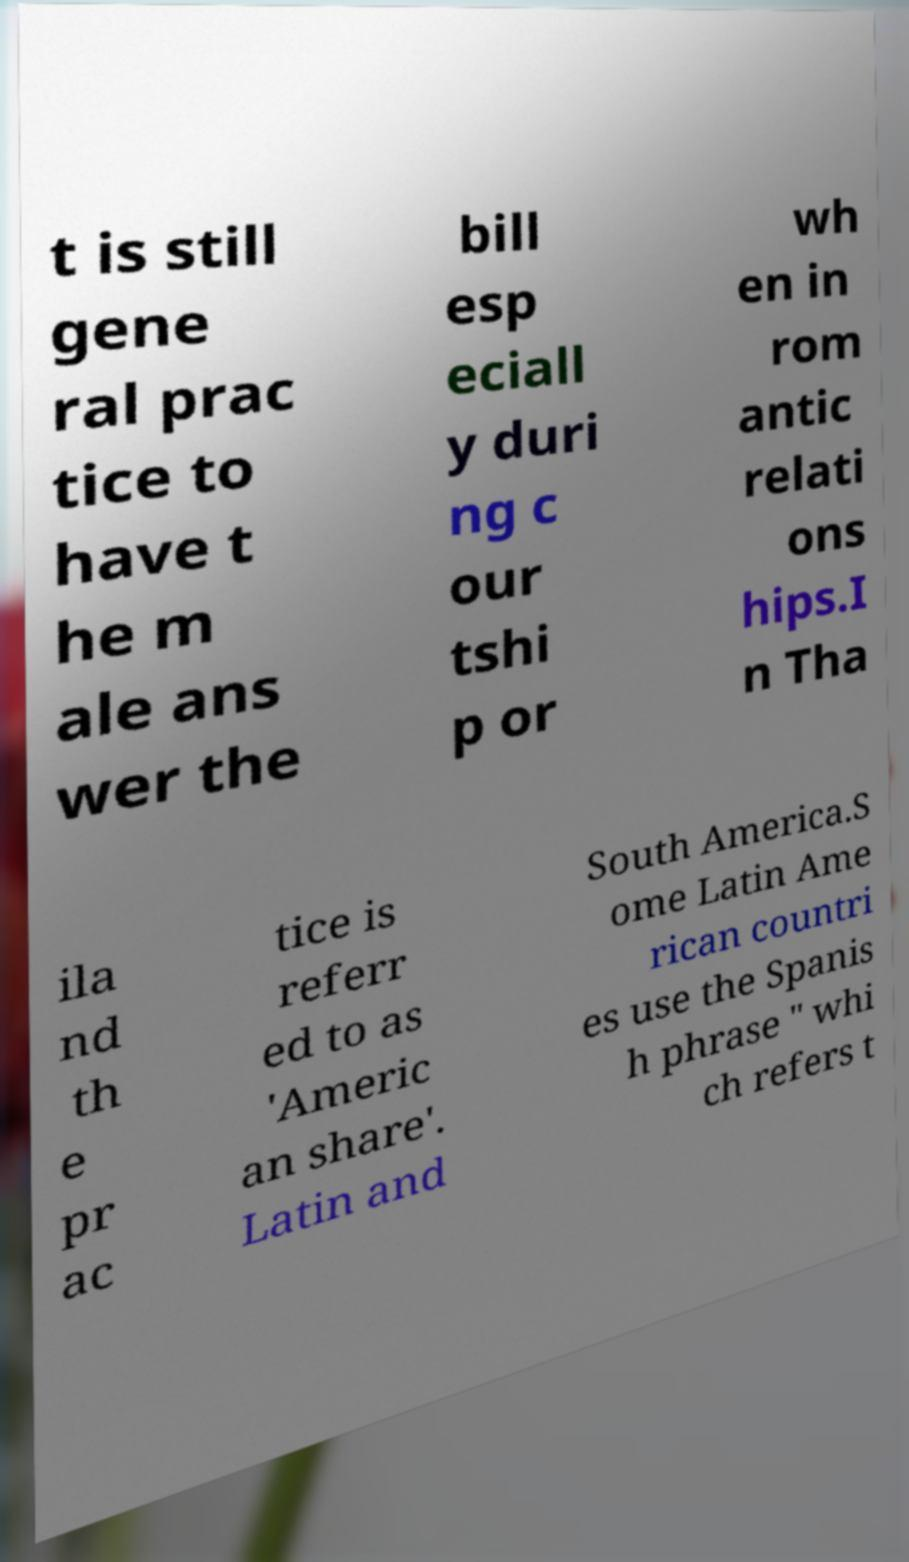I need the written content from this picture converted into text. Can you do that? t is still gene ral prac tice to have t he m ale ans wer the bill esp eciall y duri ng c our tshi p or wh en in rom antic relati ons hips.I n Tha ila nd th e pr ac tice is referr ed to as 'Americ an share'. Latin and South America.S ome Latin Ame rican countri es use the Spanis h phrase " whi ch refers t 